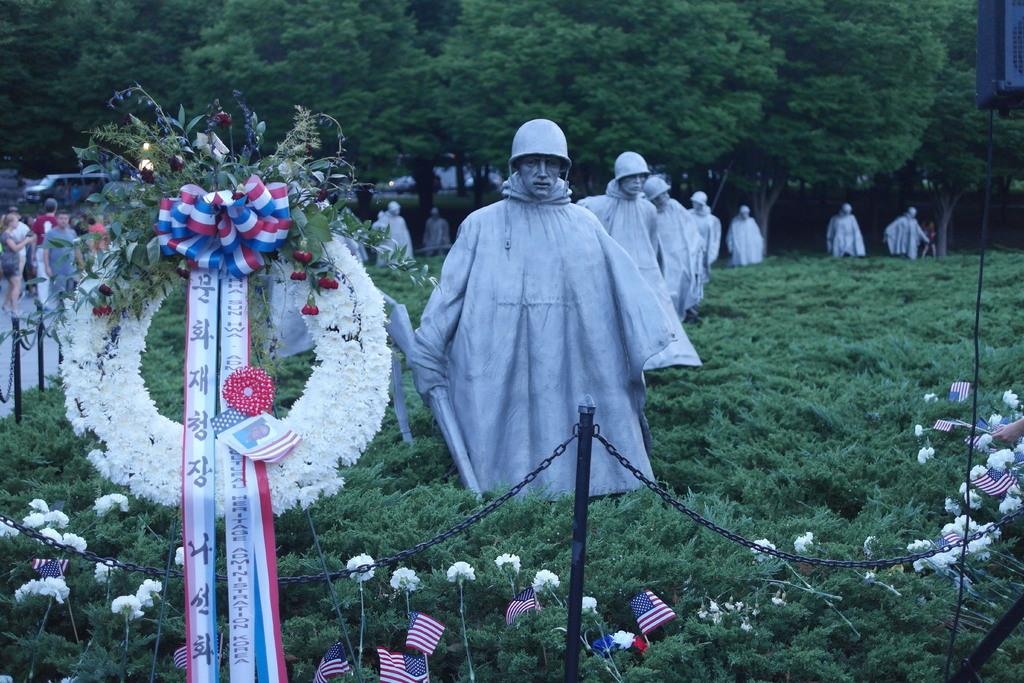What type of vegetation can be seen in the image? There are flowers, plants, and trees in the image. Are there any living beings present in the image? Yes, there are people present in the image. Where is the nest located in the image? There is no nest present in the image. Can you describe the stocking that the person is wearing in the image? There is no mention of a stocking or any clothing in the image. 